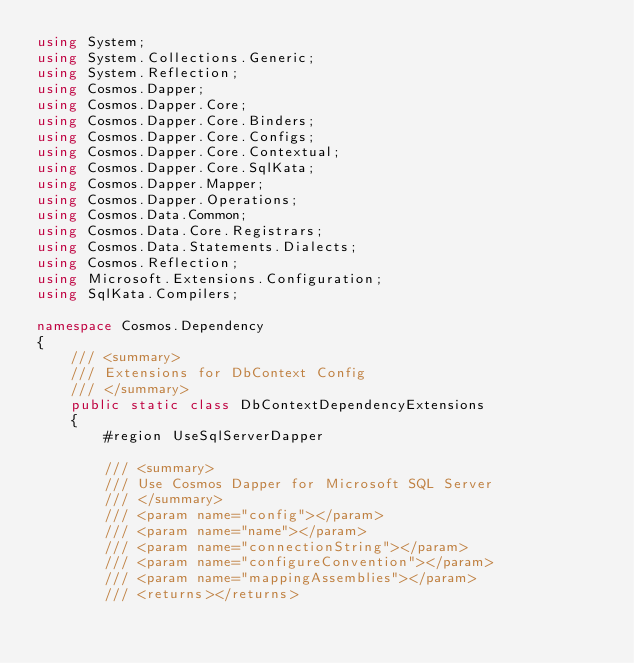Convert code to text. <code><loc_0><loc_0><loc_500><loc_500><_C#_>using System;
using System.Collections.Generic;
using System.Reflection;
using Cosmos.Dapper;
using Cosmos.Dapper.Core;
using Cosmos.Dapper.Core.Binders;
using Cosmos.Dapper.Core.Configs;
using Cosmos.Dapper.Core.Contextual;
using Cosmos.Dapper.Core.SqlKata;
using Cosmos.Dapper.Mapper;
using Cosmos.Dapper.Operations;
using Cosmos.Data.Common;
using Cosmos.Data.Core.Registrars;
using Cosmos.Data.Statements.Dialects;
using Cosmos.Reflection;
using Microsoft.Extensions.Configuration;
using SqlKata.Compilers;

namespace Cosmos.Dependency
{
    /// <summary>
    /// Extensions for DbContext Config
    /// </summary>
    public static class DbContextDependencyExtensions
    {
        #region UseSqlServerDapper

        /// <summary>
        /// Use Cosmos Dapper for Microsoft SQL Server
        /// </summary>
        /// <param name="config"></param>
        /// <param name="name"></param>
        /// <param name="connectionString"></param>
        /// <param name="configureConvention"></param>
        /// <param name="mappingAssemblies"></param>
        /// <returns></returns></code> 